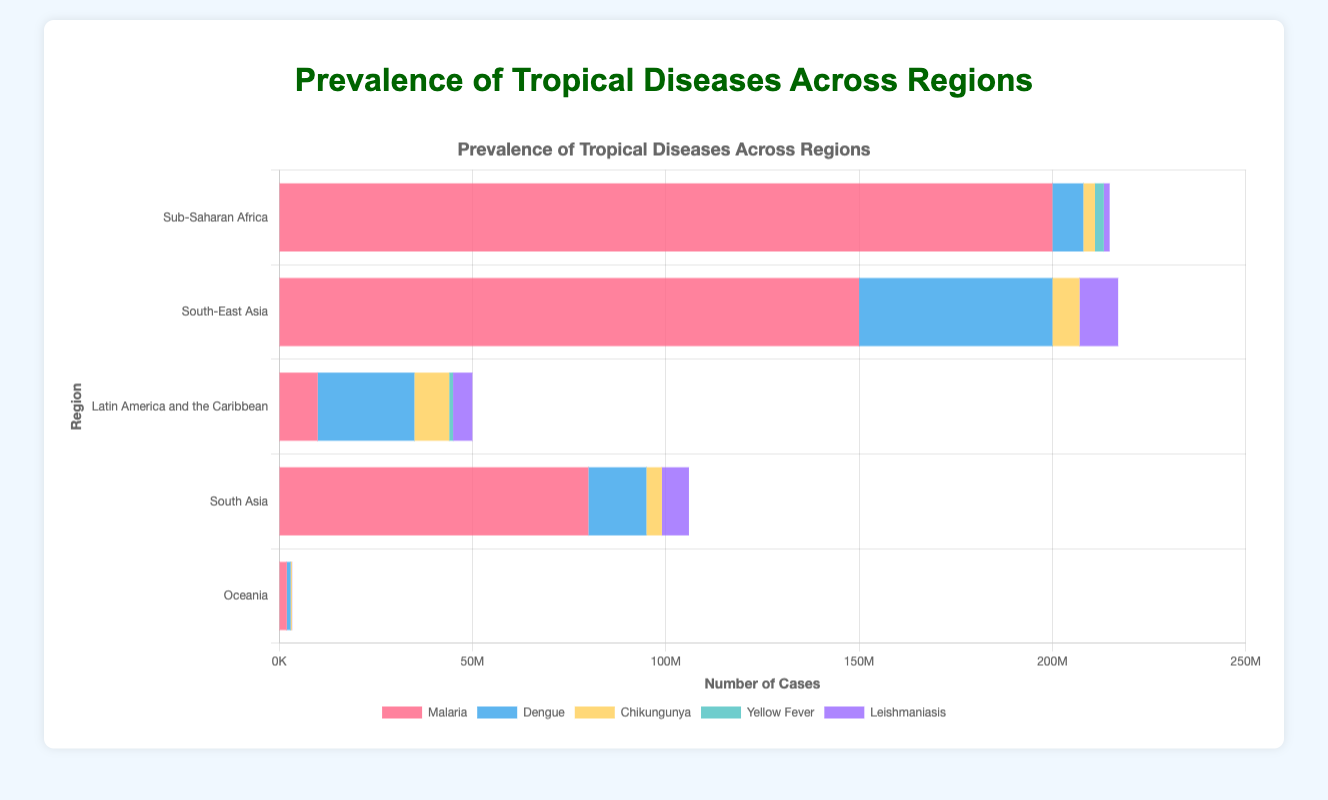Which region has the highest prevalence of Malaria? To find the region with the highest prevalence of Malaria, look for the bar with the largest length in red color representing Malaria cases. Sub-Saharan Africa has the longest red bar indicating the highest cases. Total cases for Sub-Saharan Africa are 200,000,000.
Answer: Sub-Saharan Africa Which region has no reported cases of Yellow Fever? Examine the regions for which the corresponding Yellow Fever bars, visualized in green, are absent. Both South-East Asia, South Asia, and Oceania lack Yellow Fever bars.
Answer: South-East Asia, South Asia, Oceania What is the total prevalence of Dengue in Latin America and the Caribbean and South-East Asia combined? Sum the Dengue cases from Latin America and the Caribbean and South-East Asia. Latin America and the Caribbean have 25,000,000, and South-East Asia has 50,000,000 cases of Dengue. The total is 25,000,000 + 50,000,000 = 75,000,000.
Answer: 75,000,000 Which disease has the least prevalence in Sub-Saharan Africa? Identify the smallest bar in the Sub-Saharan Africa segment. The smallest bar is for Leishmaniasis, which stands at 1,500,000 cases.
Answer: Leishmaniasis How much higher is the prevalence of Malaria in Sub-Saharan Africa than in Oceania? Subtract the Malaria cases in Oceania from the cases in Sub-Saharan Africa. Sub-Saharan Africa has 200,000,000 cases while Oceania has 2,000,000 cases. The difference is 200,000,000 - 2,000,000 = 198,000,000.
Answer: 198,000,000 What's the total number of Chikungunya cases in the chart? Sum the Chikungunya cases across all regions: 3,000,000 (Sub-Saharan Africa) + 7,000,000 (South-East Asia) + 9,000,000 (Latin America and the Caribbean) + 4,000,000 (South Asia) + 300,000 (Oceania). Total = 23,300,000.
Answer: 23,300,000 In which region is the proportion of Leishmaniasis cases to total cases the highest? Calculate the proportions for Leishmaniasis in each region by dividing the Leishmaniasis cases by the sum of total cases for each region. For Sub-Saharan Africa, it's 1,500,000 / (200,000,000 + 8,000,000 + 3,000,000 + 2,300,000 + 1,500,000). Perform a similar calculation for the other regions. Notice that Oceania has the highest proportion due to fewer total cases.
Answer: Oceania What is the average number of Malaria cases across all regions? Sum the Malaria cases across all regions and then divide by the number of regions. The sum is 200,000,000 + 150,000,000 + 10,000,000 + 80,000,000 + 2,000,000 = 442,000,000. Dividing by 5 regions gives 442,000,000 / 5 = 88,400,000.
Answer: 88,400,000 